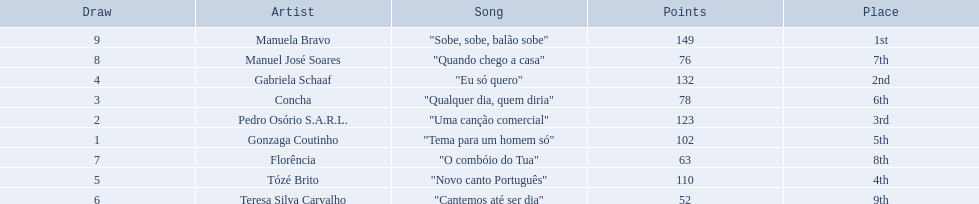What song place second in the contest? "Eu só quero". Who sang eu so quero? Gabriela Schaaf. 